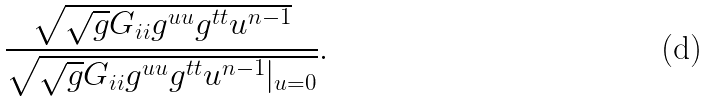<formula> <loc_0><loc_0><loc_500><loc_500>\frac { \sqrt { \sqrt { g } G _ { i i } g ^ { u u } g ^ { t t } u ^ { n - 1 } } } { \sqrt { \sqrt { g } G _ { i i } g ^ { u u } g ^ { t t } u ^ { n - 1 } | _ { u = 0 } } } .</formula> 